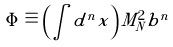Convert formula to latex. <formula><loc_0><loc_0><loc_500><loc_500>\Phi \equiv \left ( \int d ^ { n } x \right ) M _ { N } ^ { 2 } b ^ { n }</formula> 